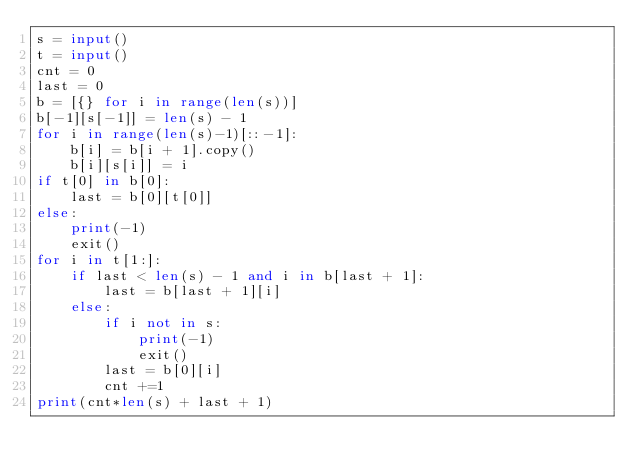Convert code to text. <code><loc_0><loc_0><loc_500><loc_500><_Python_>s = input()
t = input()
cnt = 0
last = 0
b = [{} for i in range(len(s))]
b[-1][s[-1]] = len(s) - 1
for i in range(len(s)-1)[::-1]:
    b[i] = b[i + 1].copy()
    b[i][s[i]] = i
if t[0] in b[0]:
    last = b[0][t[0]]
else:
    print(-1)
    exit()
for i in t[1:]:
    if last < len(s) - 1 and i in b[last + 1]:
        last = b[last + 1][i]
    else:
        if i not in s:
            print(-1)
            exit()
        last = b[0][i]
        cnt +=1
print(cnt*len(s) + last + 1)

</code> 